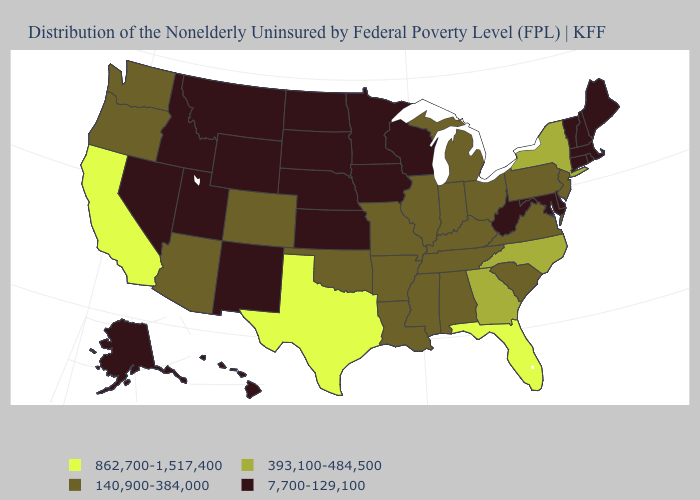What is the value of Massachusetts?
Short answer required. 7,700-129,100. What is the lowest value in the West?
Short answer required. 7,700-129,100. Name the states that have a value in the range 140,900-384,000?
Quick response, please. Alabama, Arizona, Arkansas, Colorado, Illinois, Indiana, Kentucky, Louisiana, Michigan, Mississippi, Missouri, New Jersey, Ohio, Oklahoma, Oregon, Pennsylvania, South Carolina, Tennessee, Virginia, Washington. Does Virginia have a lower value than Texas?
Quick response, please. Yes. What is the lowest value in states that border Arkansas?
Keep it brief. 140,900-384,000. Among the states that border Vermont , which have the highest value?
Quick response, please. New York. Is the legend a continuous bar?
Keep it brief. No. Name the states that have a value in the range 862,700-1,517,400?
Short answer required. California, Florida, Texas. Is the legend a continuous bar?
Concise answer only. No. What is the value of Kentucky?
Write a very short answer. 140,900-384,000. What is the lowest value in the USA?
Give a very brief answer. 7,700-129,100. What is the lowest value in states that border Vermont?
Quick response, please. 7,700-129,100. Name the states that have a value in the range 7,700-129,100?
Concise answer only. Alaska, Connecticut, Delaware, Hawaii, Idaho, Iowa, Kansas, Maine, Maryland, Massachusetts, Minnesota, Montana, Nebraska, Nevada, New Hampshire, New Mexico, North Dakota, Rhode Island, South Dakota, Utah, Vermont, West Virginia, Wisconsin, Wyoming. What is the value of New York?
Concise answer only. 393,100-484,500. Does the map have missing data?
Quick response, please. No. 